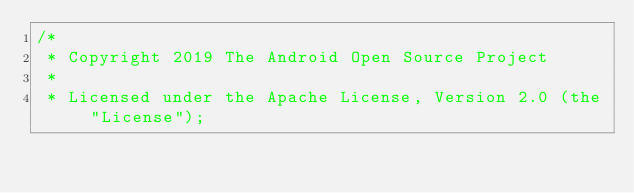Convert code to text. <code><loc_0><loc_0><loc_500><loc_500><_Java_>/*
 * Copyright 2019 The Android Open Source Project
 *
 * Licensed under the Apache License, Version 2.0 (the "License");</code> 